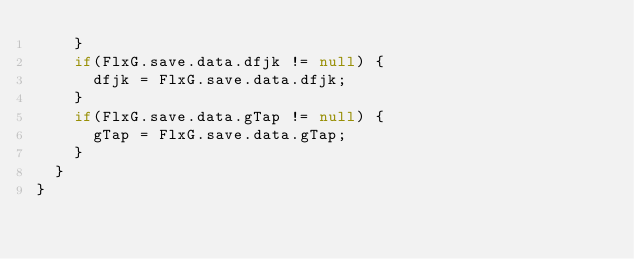Convert code to text. <code><loc_0><loc_0><loc_500><loc_500><_Haxe_>		}
		if(FlxG.save.data.dfjk != null) {
			dfjk = FlxG.save.data.dfjk;
		}
		if(FlxG.save.data.gTap != null) {
			gTap = FlxG.save.data.gTap;
		}
	}
}</code> 